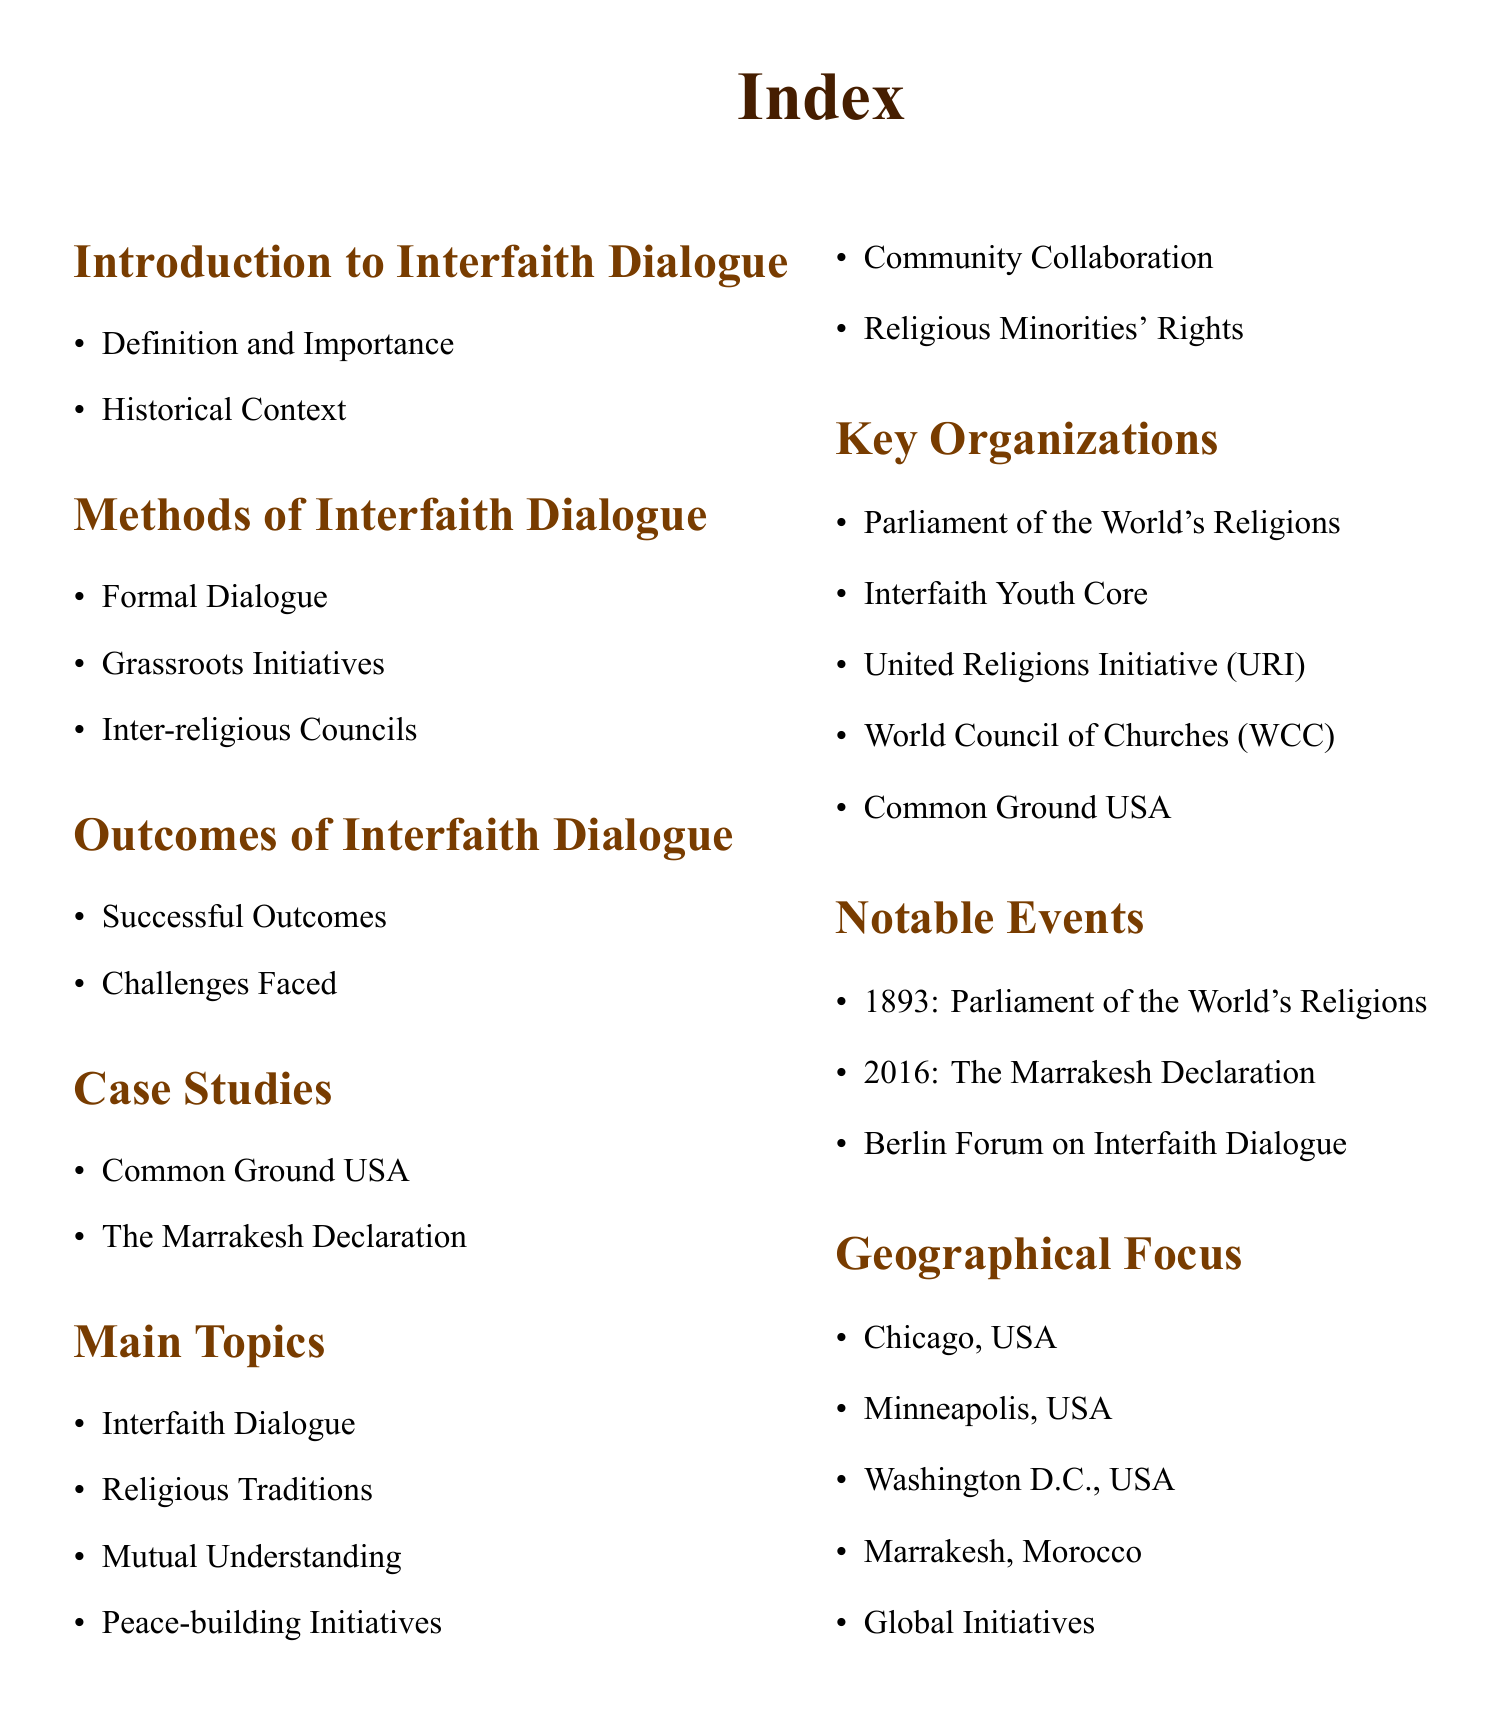What is the main focus of the index? The main focus of the index is interfaith dialogue practices, including methods and outcomes.
Answer: Interfaith Dialogue Practices What organization is listed first among key organizations? The first organization listed is the Parliament of the World's Religions.
Answer: Parliament of the World's Religions Which event is associated with the year 2016? The event associated with 2016 is the Marrakesh Declaration.
Answer: The Marrakesh Declaration Name one case study mentioned in the document. One case study mentioned is Common Ground USA.
Answer: Common Ground USA What are the two types of dialogue methods identified? The document identifies formal dialogue and grassroots initiatives as two methods.
Answer: Formal Dialogue and Grassroots Initiatives What geographical location is listed last in the geographical focus section? The last geographical location listed is Global Initiatives.
Answer: Global Initiatives How many successful outcomes are mentioned in the outcomes section? The outcomes section has one category titled Successful Outcomes, without a specific number.
Answer: Successful Outcomes What does the introduction section include? The introduction section includes definitions and historical context.
Answer: Definition and Importance, Historical Context What is a challenge faced in interfaith dialogue according to the document? The document lists challenges faced in interfaith dialogue but does not specify.
Answer: Challenges Faced 